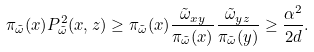<formula> <loc_0><loc_0><loc_500><loc_500>\pi _ { \tilde { \omega } } ( x ) P ^ { 2 } _ { \tilde { \omega } } ( x , z ) \geq \pi _ { \tilde { \omega } } ( x ) \frac { \tilde { \omega } _ { x y } } { \pi _ { \tilde { \omega } } ( x ) } \frac { \tilde { \omega } _ { y z } } { \pi _ { \tilde { \omega } } ( y ) } \geq \frac { \alpha ^ { 2 } } { 2 d } .</formula> 